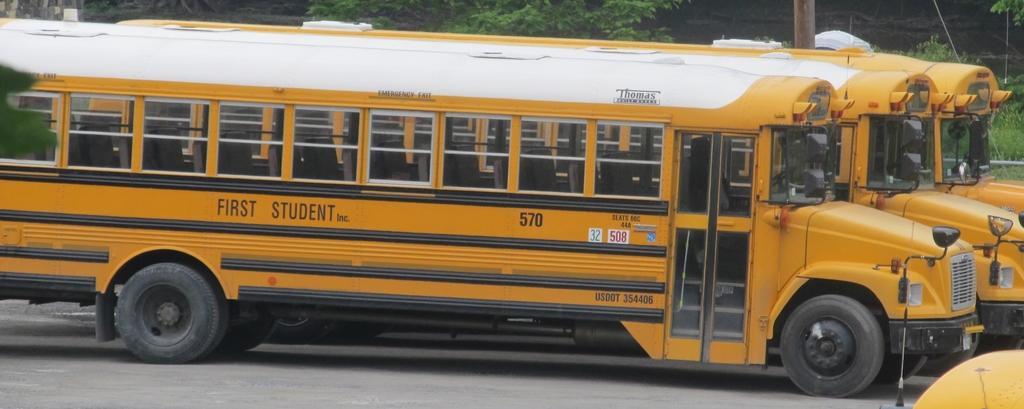Could you give a brief overview of what you see in this image? In the center of the image there are buses on the road. In the background of the image there are trees. There is a pole. 